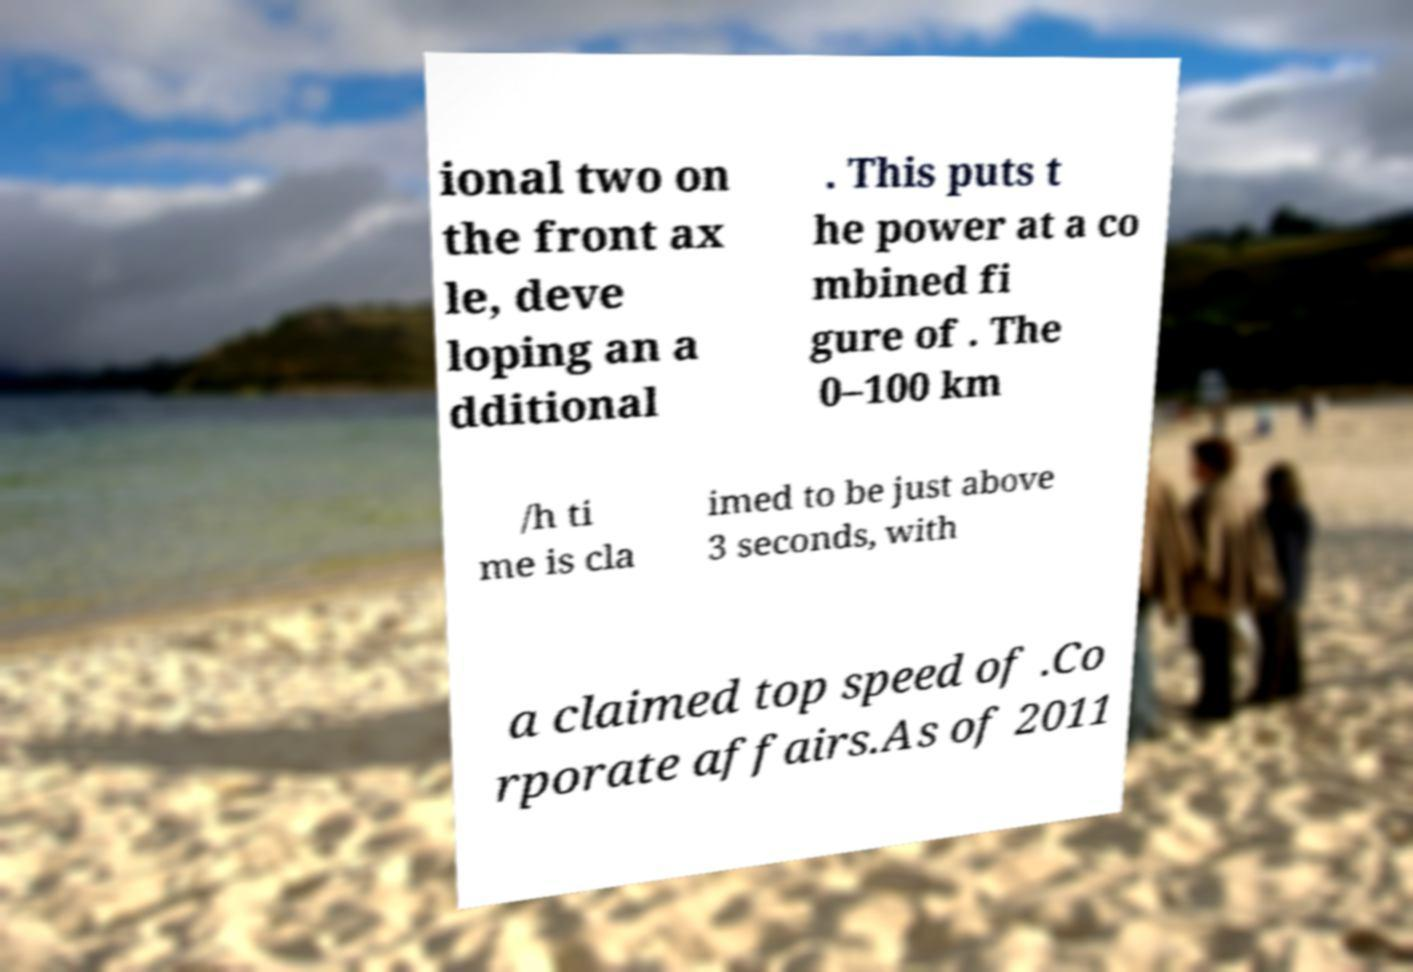What messages or text are displayed in this image? I need them in a readable, typed format. ional two on the front ax le, deve loping an a dditional . This puts t he power at a co mbined fi gure of . The 0–100 km /h ti me is cla imed to be just above 3 seconds, with a claimed top speed of .Co rporate affairs.As of 2011 